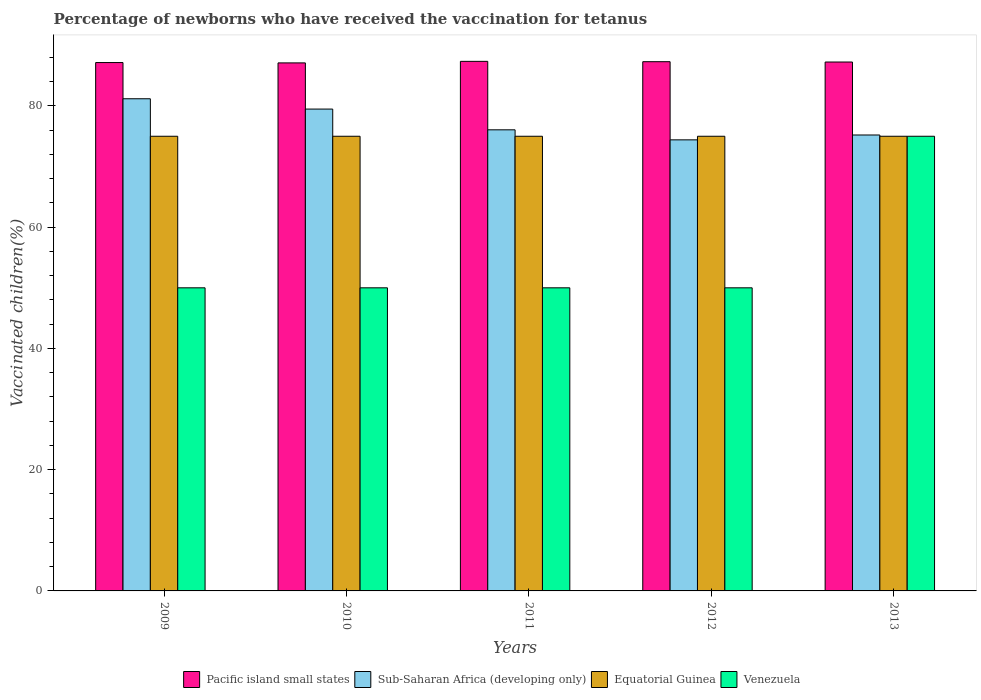How many different coloured bars are there?
Provide a short and direct response. 4. How many bars are there on the 5th tick from the left?
Your answer should be compact. 4. How many bars are there on the 1st tick from the right?
Offer a terse response. 4. What is the label of the 2nd group of bars from the left?
Your response must be concise. 2010. What is the percentage of vaccinated children in Venezuela in 2010?
Your answer should be very brief. 50. Across all years, what is the maximum percentage of vaccinated children in Pacific island small states?
Offer a terse response. 87.36. In which year was the percentage of vaccinated children in Equatorial Guinea minimum?
Offer a terse response. 2009. What is the total percentage of vaccinated children in Venezuela in the graph?
Make the answer very short. 275. What is the difference between the percentage of vaccinated children in Sub-Saharan Africa (developing only) in 2011 and that in 2013?
Your response must be concise. 0.85. What is the difference between the percentage of vaccinated children in Equatorial Guinea in 2012 and the percentage of vaccinated children in Sub-Saharan Africa (developing only) in 2013?
Keep it short and to the point. -0.21. In the year 2011, what is the difference between the percentage of vaccinated children in Pacific island small states and percentage of vaccinated children in Venezuela?
Your response must be concise. 37.36. In how many years, is the percentage of vaccinated children in Equatorial Guinea greater than 8 %?
Offer a terse response. 5. What is the ratio of the percentage of vaccinated children in Sub-Saharan Africa (developing only) in 2009 to that in 2011?
Offer a very short reply. 1.07. Is the percentage of vaccinated children in Venezuela in 2011 less than that in 2013?
Make the answer very short. Yes. Is the difference between the percentage of vaccinated children in Pacific island small states in 2011 and 2013 greater than the difference between the percentage of vaccinated children in Venezuela in 2011 and 2013?
Give a very brief answer. Yes. What is the difference between the highest and the lowest percentage of vaccinated children in Venezuela?
Give a very brief answer. 25. Is the sum of the percentage of vaccinated children in Equatorial Guinea in 2011 and 2012 greater than the maximum percentage of vaccinated children in Pacific island small states across all years?
Your response must be concise. Yes. Is it the case that in every year, the sum of the percentage of vaccinated children in Sub-Saharan Africa (developing only) and percentage of vaccinated children in Equatorial Guinea is greater than the sum of percentage of vaccinated children in Venezuela and percentage of vaccinated children in Pacific island small states?
Make the answer very short. Yes. What does the 3rd bar from the left in 2013 represents?
Give a very brief answer. Equatorial Guinea. What does the 4th bar from the right in 2011 represents?
Ensure brevity in your answer.  Pacific island small states. Is it the case that in every year, the sum of the percentage of vaccinated children in Venezuela and percentage of vaccinated children in Sub-Saharan Africa (developing only) is greater than the percentage of vaccinated children in Equatorial Guinea?
Give a very brief answer. Yes. How many bars are there?
Provide a succinct answer. 20. Are all the bars in the graph horizontal?
Offer a very short reply. No. How many years are there in the graph?
Provide a short and direct response. 5. Are the values on the major ticks of Y-axis written in scientific E-notation?
Provide a succinct answer. No. Where does the legend appear in the graph?
Ensure brevity in your answer.  Bottom center. How many legend labels are there?
Make the answer very short. 4. What is the title of the graph?
Provide a succinct answer. Percentage of newborns who have received the vaccination for tetanus. What is the label or title of the X-axis?
Keep it short and to the point. Years. What is the label or title of the Y-axis?
Your response must be concise. Vaccinated children(%). What is the Vaccinated children(%) in Pacific island small states in 2009?
Your answer should be compact. 87.16. What is the Vaccinated children(%) in Sub-Saharan Africa (developing only) in 2009?
Provide a succinct answer. 81.19. What is the Vaccinated children(%) in Equatorial Guinea in 2009?
Offer a terse response. 75. What is the Vaccinated children(%) of Pacific island small states in 2010?
Keep it short and to the point. 87.1. What is the Vaccinated children(%) in Sub-Saharan Africa (developing only) in 2010?
Offer a very short reply. 79.49. What is the Vaccinated children(%) in Equatorial Guinea in 2010?
Provide a short and direct response. 75. What is the Vaccinated children(%) in Pacific island small states in 2011?
Offer a terse response. 87.36. What is the Vaccinated children(%) of Sub-Saharan Africa (developing only) in 2011?
Keep it short and to the point. 76.06. What is the Vaccinated children(%) in Pacific island small states in 2012?
Your response must be concise. 87.3. What is the Vaccinated children(%) of Sub-Saharan Africa (developing only) in 2012?
Offer a very short reply. 74.41. What is the Vaccinated children(%) in Equatorial Guinea in 2012?
Make the answer very short. 75. What is the Vaccinated children(%) of Pacific island small states in 2013?
Make the answer very short. 87.25. What is the Vaccinated children(%) in Sub-Saharan Africa (developing only) in 2013?
Provide a short and direct response. 75.21. Across all years, what is the maximum Vaccinated children(%) in Pacific island small states?
Keep it short and to the point. 87.36. Across all years, what is the maximum Vaccinated children(%) of Sub-Saharan Africa (developing only)?
Your response must be concise. 81.19. Across all years, what is the maximum Vaccinated children(%) in Equatorial Guinea?
Provide a short and direct response. 75. Across all years, what is the maximum Vaccinated children(%) in Venezuela?
Provide a short and direct response. 75. Across all years, what is the minimum Vaccinated children(%) of Pacific island small states?
Provide a succinct answer. 87.1. Across all years, what is the minimum Vaccinated children(%) in Sub-Saharan Africa (developing only)?
Ensure brevity in your answer.  74.41. Across all years, what is the minimum Vaccinated children(%) in Equatorial Guinea?
Give a very brief answer. 75. What is the total Vaccinated children(%) of Pacific island small states in the graph?
Offer a very short reply. 436.17. What is the total Vaccinated children(%) of Sub-Saharan Africa (developing only) in the graph?
Provide a succinct answer. 386.35. What is the total Vaccinated children(%) of Equatorial Guinea in the graph?
Keep it short and to the point. 375. What is the total Vaccinated children(%) in Venezuela in the graph?
Keep it short and to the point. 275. What is the difference between the Vaccinated children(%) in Pacific island small states in 2009 and that in 2010?
Keep it short and to the point. 0.06. What is the difference between the Vaccinated children(%) in Sub-Saharan Africa (developing only) in 2009 and that in 2010?
Provide a short and direct response. 1.7. What is the difference between the Vaccinated children(%) of Equatorial Guinea in 2009 and that in 2010?
Your response must be concise. 0. What is the difference between the Vaccinated children(%) of Pacific island small states in 2009 and that in 2011?
Your answer should be compact. -0.2. What is the difference between the Vaccinated children(%) of Sub-Saharan Africa (developing only) in 2009 and that in 2011?
Keep it short and to the point. 5.13. What is the difference between the Vaccinated children(%) of Equatorial Guinea in 2009 and that in 2011?
Offer a very short reply. 0. What is the difference between the Vaccinated children(%) of Pacific island small states in 2009 and that in 2012?
Ensure brevity in your answer.  -0.14. What is the difference between the Vaccinated children(%) of Sub-Saharan Africa (developing only) in 2009 and that in 2012?
Make the answer very short. 6.78. What is the difference between the Vaccinated children(%) in Venezuela in 2009 and that in 2012?
Provide a succinct answer. 0. What is the difference between the Vaccinated children(%) in Pacific island small states in 2009 and that in 2013?
Keep it short and to the point. -0.09. What is the difference between the Vaccinated children(%) in Sub-Saharan Africa (developing only) in 2009 and that in 2013?
Make the answer very short. 5.98. What is the difference between the Vaccinated children(%) of Venezuela in 2009 and that in 2013?
Give a very brief answer. -25. What is the difference between the Vaccinated children(%) of Pacific island small states in 2010 and that in 2011?
Give a very brief answer. -0.25. What is the difference between the Vaccinated children(%) of Sub-Saharan Africa (developing only) in 2010 and that in 2011?
Your answer should be compact. 3.42. What is the difference between the Vaccinated children(%) of Venezuela in 2010 and that in 2011?
Offer a very short reply. 0. What is the difference between the Vaccinated children(%) in Pacific island small states in 2010 and that in 2012?
Your answer should be very brief. -0.2. What is the difference between the Vaccinated children(%) in Sub-Saharan Africa (developing only) in 2010 and that in 2012?
Keep it short and to the point. 5.08. What is the difference between the Vaccinated children(%) in Venezuela in 2010 and that in 2012?
Give a very brief answer. 0. What is the difference between the Vaccinated children(%) in Pacific island small states in 2010 and that in 2013?
Your answer should be very brief. -0.14. What is the difference between the Vaccinated children(%) in Sub-Saharan Africa (developing only) in 2010 and that in 2013?
Your answer should be compact. 4.28. What is the difference between the Vaccinated children(%) in Equatorial Guinea in 2010 and that in 2013?
Provide a short and direct response. 0. What is the difference between the Vaccinated children(%) of Venezuela in 2010 and that in 2013?
Offer a terse response. -25. What is the difference between the Vaccinated children(%) of Pacific island small states in 2011 and that in 2012?
Your response must be concise. 0.06. What is the difference between the Vaccinated children(%) in Sub-Saharan Africa (developing only) in 2011 and that in 2012?
Provide a short and direct response. 1.65. What is the difference between the Vaccinated children(%) in Equatorial Guinea in 2011 and that in 2012?
Offer a terse response. 0. What is the difference between the Vaccinated children(%) of Venezuela in 2011 and that in 2012?
Keep it short and to the point. 0. What is the difference between the Vaccinated children(%) in Pacific island small states in 2011 and that in 2013?
Ensure brevity in your answer.  0.11. What is the difference between the Vaccinated children(%) in Sub-Saharan Africa (developing only) in 2011 and that in 2013?
Your answer should be compact. 0.85. What is the difference between the Vaccinated children(%) in Venezuela in 2011 and that in 2013?
Give a very brief answer. -25. What is the difference between the Vaccinated children(%) in Pacific island small states in 2012 and that in 2013?
Make the answer very short. 0.06. What is the difference between the Vaccinated children(%) in Sub-Saharan Africa (developing only) in 2012 and that in 2013?
Provide a short and direct response. -0.8. What is the difference between the Vaccinated children(%) in Equatorial Guinea in 2012 and that in 2013?
Your answer should be very brief. 0. What is the difference between the Vaccinated children(%) of Pacific island small states in 2009 and the Vaccinated children(%) of Sub-Saharan Africa (developing only) in 2010?
Your answer should be compact. 7.67. What is the difference between the Vaccinated children(%) of Pacific island small states in 2009 and the Vaccinated children(%) of Equatorial Guinea in 2010?
Give a very brief answer. 12.16. What is the difference between the Vaccinated children(%) in Pacific island small states in 2009 and the Vaccinated children(%) in Venezuela in 2010?
Ensure brevity in your answer.  37.16. What is the difference between the Vaccinated children(%) in Sub-Saharan Africa (developing only) in 2009 and the Vaccinated children(%) in Equatorial Guinea in 2010?
Offer a terse response. 6.19. What is the difference between the Vaccinated children(%) of Sub-Saharan Africa (developing only) in 2009 and the Vaccinated children(%) of Venezuela in 2010?
Offer a very short reply. 31.19. What is the difference between the Vaccinated children(%) in Equatorial Guinea in 2009 and the Vaccinated children(%) in Venezuela in 2010?
Provide a short and direct response. 25. What is the difference between the Vaccinated children(%) of Pacific island small states in 2009 and the Vaccinated children(%) of Sub-Saharan Africa (developing only) in 2011?
Offer a terse response. 11.1. What is the difference between the Vaccinated children(%) in Pacific island small states in 2009 and the Vaccinated children(%) in Equatorial Guinea in 2011?
Keep it short and to the point. 12.16. What is the difference between the Vaccinated children(%) of Pacific island small states in 2009 and the Vaccinated children(%) of Venezuela in 2011?
Ensure brevity in your answer.  37.16. What is the difference between the Vaccinated children(%) in Sub-Saharan Africa (developing only) in 2009 and the Vaccinated children(%) in Equatorial Guinea in 2011?
Offer a very short reply. 6.19. What is the difference between the Vaccinated children(%) in Sub-Saharan Africa (developing only) in 2009 and the Vaccinated children(%) in Venezuela in 2011?
Your response must be concise. 31.19. What is the difference between the Vaccinated children(%) of Pacific island small states in 2009 and the Vaccinated children(%) of Sub-Saharan Africa (developing only) in 2012?
Provide a short and direct response. 12.75. What is the difference between the Vaccinated children(%) of Pacific island small states in 2009 and the Vaccinated children(%) of Equatorial Guinea in 2012?
Keep it short and to the point. 12.16. What is the difference between the Vaccinated children(%) in Pacific island small states in 2009 and the Vaccinated children(%) in Venezuela in 2012?
Your answer should be compact. 37.16. What is the difference between the Vaccinated children(%) of Sub-Saharan Africa (developing only) in 2009 and the Vaccinated children(%) of Equatorial Guinea in 2012?
Provide a short and direct response. 6.19. What is the difference between the Vaccinated children(%) in Sub-Saharan Africa (developing only) in 2009 and the Vaccinated children(%) in Venezuela in 2012?
Provide a short and direct response. 31.19. What is the difference between the Vaccinated children(%) in Pacific island small states in 2009 and the Vaccinated children(%) in Sub-Saharan Africa (developing only) in 2013?
Offer a terse response. 11.95. What is the difference between the Vaccinated children(%) in Pacific island small states in 2009 and the Vaccinated children(%) in Equatorial Guinea in 2013?
Your answer should be compact. 12.16. What is the difference between the Vaccinated children(%) in Pacific island small states in 2009 and the Vaccinated children(%) in Venezuela in 2013?
Your answer should be very brief. 12.16. What is the difference between the Vaccinated children(%) in Sub-Saharan Africa (developing only) in 2009 and the Vaccinated children(%) in Equatorial Guinea in 2013?
Ensure brevity in your answer.  6.19. What is the difference between the Vaccinated children(%) of Sub-Saharan Africa (developing only) in 2009 and the Vaccinated children(%) of Venezuela in 2013?
Your response must be concise. 6.19. What is the difference between the Vaccinated children(%) in Pacific island small states in 2010 and the Vaccinated children(%) in Sub-Saharan Africa (developing only) in 2011?
Offer a very short reply. 11.04. What is the difference between the Vaccinated children(%) of Pacific island small states in 2010 and the Vaccinated children(%) of Equatorial Guinea in 2011?
Provide a succinct answer. 12.1. What is the difference between the Vaccinated children(%) in Pacific island small states in 2010 and the Vaccinated children(%) in Venezuela in 2011?
Keep it short and to the point. 37.1. What is the difference between the Vaccinated children(%) of Sub-Saharan Africa (developing only) in 2010 and the Vaccinated children(%) of Equatorial Guinea in 2011?
Your answer should be very brief. 4.49. What is the difference between the Vaccinated children(%) of Sub-Saharan Africa (developing only) in 2010 and the Vaccinated children(%) of Venezuela in 2011?
Your response must be concise. 29.49. What is the difference between the Vaccinated children(%) of Pacific island small states in 2010 and the Vaccinated children(%) of Sub-Saharan Africa (developing only) in 2012?
Ensure brevity in your answer.  12.69. What is the difference between the Vaccinated children(%) in Pacific island small states in 2010 and the Vaccinated children(%) in Equatorial Guinea in 2012?
Make the answer very short. 12.1. What is the difference between the Vaccinated children(%) in Pacific island small states in 2010 and the Vaccinated children(%) in Venezuela in 2012?
Your answer should be compact. 37.1. What is the difference between the Vaccinated children(%) of Sub-Saharan Africa (developing only) in 2010 and the Vaccinated children(%) of Equatorial Guinea in 2012?
Provide a short and direct response. 4.49. What is the difference between the Vaccinated children(%) of Sub-Saharan Africa (developing only) in 2010 and the Vaccinated children(%) of Venezuela in 2012?
Make the answer very short. 29.49. What is the difference between the Vaccinated children(%) in Pacific island small states in 2010 and the Vaccinated children(%) in Sub-Saharan Africa (developing only) in 2013?
Make the answer very short. 11.89. What is the difference between the Vaccinated children(%) in Pacific island small states in 2010 and the Vaccinated children(%) in Equatorial Guinea in 2013?
Give a very brief answer. 12.1. What is the difference between the Vaccinated children(%) of Pacific island small states in 2010 and the Vaccinated children(%) of Venezuela in 2013?
Give a very brief answer. 12.1. What is the difference between the Vaccinated children(%) in Sub-Saharan Africa (developing only) in 2010 and the Vaccinated children(%) in Equatorial Guinea in 2013?
Make the answer very short. 4.49. What is the difference between the Vaccinated children(%) of Sub-Saharan Africa (developing only) in 2010 and the Vaccinated children(%) of Venezuela in 2013?
Keep it short and to the point. 4.49. What is the difference between the Vaccinated children(%) of Equatorial Guinea in 2010 and the Vaccinated children(%) of Venezuela in 2013?
Your answer should be compact. 0. What is the difference between the Vaccinated children(%) of Pacific island small states in 2011 and the Vaccinated children(%) of Sub-Saharan Africa (developing only) in 2012?
Ensure brevity in your answer.  12.95. What is the difference between the Vaccinated children(%) of Pacific island small states in 2011 and the Vaccinated children(%) of Equatorial Guinea in 2012?
Ensure brevity in your answer.  12.36. What is the difference between the Vaccinated children(%) in Pacific island small states in 2011 and the Vaccinated children(%) in Venezuela in 2012?
Your response must be concise. 37.36. What is the difference between the Vaccinated children(%) in Sub-Saharan Africa (developing only) in 2011 and the Vaccinated children(%) in Equatorial Guinea in 2012?
Make the answer very short. 1.06. What is the difference between the Vaccinated children(%) of Sub-Saharan Africa (developing only) in 2011 and the Vaccinated children(%) of Venezuela in 2012?
Provide a short and direct response. 26.06. What is the difference between the Vaccinated children(%) of Equatorial Guinea in 2011 and the Vaccinated children(%) of Venezuela in 2012?
Ensure brevity in your answer.  25. What is the difference between the Vaccinated children(%) in Pacific island small states in 2011 and the Vaccinated children(%) in Sub-Saharan Africa (developing only) in 2013?
Offer a terse response. 12.15. What is the difference between the Vaccinated children(%) in Pacific island small states in 2011 and the Vaccinated children(%) in Equatorial Guinea in 2013?
Offer a very short reply. 12.36. What is the difference between the Vaccinated children(%) in Pacific island small states in 2011 and the Vaccinated children(%) in Venezuela in 2013?
Make the answer very short. 12.36. What is the difference between the Vaccinated children(%) of Sub-Saharan Africa (developing only) in 2011 and the Vaccinated children(%) of Equatorial Guinea in 2013?
Your response must be concise. 1.06. What is the difference between the Vaccinated children(%) of Sub-Saharan Africa (developing only) in 2011 and the Vaccinated children(%) of Venezuela in 2013?
Ensure brevity in your answer.  1.06. What is the difference between the Vaccinated children(%) of Pacific island small states in 2012 and the Vaccinated children(%) of Sub-Saharan Africa (developing only) in 2013?
Your answer should be compact. 12.09. What is the difference between the Vaccinated children(%) in Pacific island small states in 2012 and the Vaccinated children(%) in Equatorial Guinea in 2013?
Offer a terse response. 12.3. What is the difference between the Vaccinated children(%) in Pacific island small states in 2012 and the Vaccinated children(%) in Venezuela in 2013?
Offer a very short reply. 12.3. What is the difference between the Vaccinated children(%) in Sub-Saharan Africa (developing only) in 2012 and the Vaccinated children(%) in Equatorial Guinea in 2013?
Offer a terse response. -0.59. What is the difference between the Vaccinated children(%) of Sub-Saharan Africa (developing only) in 2012 and the Vaccinated children(%) of Venezuela in 2013?
Your answer should be very brief. -0.59. What is the average Vaccinated children(%) in Pacific island small states per year?
Provide a succinct answer. 87.23. What is the average Vaccinated children(%) in Sub-Saharan Africa (developing only) per year?
Your response must be concise. 77.27. What is the average Vaccinated children(%) in Equatorial Guinea per year?
Keep it short and to the point. 75. In the year 2009, what is the difference between the Vaccinated children(%) of Pacific island small states and Vaccinated children(%) of Sub-Saharan Africa (developing only)?
Your answer should be compact. 5.97. In the year 2009, what is the difference between the Vaccinated children(%) in Pacific island small states and Vaccinated children(%) in Equatorial Guinea?
Provide a succinct answer. 12.16. In the year 2009, what is the difference between the Vaccinated children(%) of Pacific island small states and Vaccinated children(%) of Venezuela?
Ensure brevity in your answer.  37.16. In the year 2009, what is the difference between the Vaccinated children(%) of Sub-Saharan Africa (developing only) and Vaccinated children(%) of Equatorial Guinea?
Offer a terse response. 6.19. In the year 2009, what is the difference between the Vaccinated children(%) of Sub-Saharan Africa (developing only) and Vaccinated children(%) of Venezuela?
Keep it short and to the point. 31.19. In the year 2010, what is the difference between the Vaccinated children(%) in Pacific island small states and Vaccinated children(%) in Sub-Saharan Africa (developing only)?
Your answer should be very brief. 7.62. In the year 2010, what is the difference between the Vaccinated children(%) of Pacific island small states and Vaccinated children(%) of Equatorial Guinea?
Provide a short and direct response. 12.1. In the year 2010, what is the difference between the Vaccinated children(%) in Pacific island small states and Vaccinated children(%) in Venezuela?
Your response must be concise. 37.1. In the year 2010, what is the difference between the Vaccinated children(%) of Sub-Saharan Africa (developing only) and Vaccinated children(%) of Equatorial Guinea?
Offer a terse response. 4.49. In the year 2010, what is the difference between the Vaccinated children(%) of Sub-Saharan Africa (developing only) and Vaccinated children(%) of Venezuela?
Offer a very short reply. 29.49. In the year 2010, what is the difference between the Vaccinated children(%) of Equatorial Guinea and Vaccinated children(%) of Venezuela?
Provide a succinct answer. 25. In the year 2011, what is the difference between the Vaccinated children(%) of Pacific island small states and Vaccinated children(%) of Sub-Saharan Africa (developing only)?
Provide a short and direct response. 11.3. In the year 2011, what is the difference between the Vaccinated children(%) of Pacific island small states and Vaccinated children(%) of Equatorial Guinea?
Keep it short and to the point. 12.36. In the year 2011, what is the difference between the Vaccinated children(%) of Pacific island small states and Vaccinated children(%) of Venezuela?
Provide a succinct answer. 37.36. In the year 2011, what is the difference between the Vaccinated children(%) of Sub-Saharan Africa (developing only) and Vaccinated children(%) of Equatorial Guinea?
Offer a very short reply. 1.06. In the year 2011, what is the difference between the Vaccinated children(%) of Sub-Saharan Africa (developing only) and Vaccinated children(%) of Venezuela?
Give a very brief answer. 26.06. In the year 2012, what is the difference between the Vaccinated children(%) in Pacific island small states and Vaccinated children(%) in Sub-Saharan Africa (developing only)?
Your answer should be very brief. 12.89. In the year 2012, what is the difference between the Vaccinated children(%) of Pacific island small states and Vaccinated children(%) of Equatorial Guinea?
Your answer should be very brief. 12.3. In the year 2012, what is the difference between the Vaccinated children(%) of Pacific island small states and Vaccinated children(%) of Venezuela?
Provide a succinct answer. 37.3. In the year 2012, what is the difference between the Vaccinated children(%) of Sub-Saharan Africa (developing only) and Vaccinated children(%) of Equatorial Guinea?
Your response must be concise. -0.59. In the year 2012, what is the difference between the Vaccinated children(%) in Sub-Saharan Africa (developing only) and Vaccinated children(%) in Venezuela?
Your response must be concise. 24.41. In the year 2012, what is the difference between the Vaccinated children(%) in Equatorial Guinea and Vaccinated children(%) in Venezuela?
Make the answer very short. 25. In the year 2013, what is the difference between the Vaccinated children(%) of Pacific island small states and Vaccinated children(%) of Sub-Saharan Africa (developing only)?
Keep it short and to the point. 12.04. In the year 2013, what is the difference between the Vaccinated children(%) of Pacific island small states and Vaccinated children(%) of Equatorial Guinea?
Offer a very short reply. 12.25. In the year 2013, what is the difference between the Vaccinated children(%) in Pacific island small states and Vaccinated children(%) in Venezuela?
Ensure brevity in your answer.  12.25. In the year 2013, what is the difference between the Vaccinated children(%) of Sub-Saharan Africa (developing only) and Vaccinated children(%) of Equatorial Guinea?
Provide a succinct answer. 0.21. In the year 2013, what is the difference between the Vaccinated children(%) of Sub-Saharan Africa (developing only) and Vaccinated children(%) of Venezuela?
Keep it short and to the point. 0.21. In the year 2013, what is the difference between the Vaccinated children(%) of Equatorial Guinea and Vaccinated children(%) of Venezuela?
Ensure brevity in your answer.  0. What is the ratio of the Vaccinated children(%) of Sub-Saharan Africa (developing only) in 2009 to that in 2010?
Give a very brief answer. 1.02. What is the ratio of the Vaccinated children(%) of Sub-Saharan Africa (developing only) in 2009 to that in 2011?
Your answer should be compact. 1.07. What is the ratio of the Vaccinated children(%) in Sub-Saharan Africa (developing only) in 2009 to that in 2012?
Offer a terse response. 1.09. What is the ratio of the Vaccinated children(%) of Equatorial Guinea in 2009 to that in 2012?
Provide a short and direct response. 1. What is the ratio of the Vaccinated children(%) of Sub-Saharan Africa (developing only) in 2009 to that in 2013?
Ensure brevity in your answer.  1.08. What is the ratio of the Vaccinated children(%) of Venezuela in 2009 to that in 2013?
Your answer should be very brief. 0.67. What is the ratio of the Vaccinated children(%) of Pacific island small states in 2010 to that in 2011?
Ensure brevity in your answer.  1. What is the ratio of the Vaccinated children(%) in Sub-Saharan Africa (developing only) in 2010 to that in 2011?
Ensure brevity in your answer.  1.04. What is the ratio of the Vaccinated children(%) of Equatorial Guinea in 2010 to that in 2011?
Provide a short and direct response. 1. What is the ratio of the Vaccinated children(%) in Venezuela in 2010 to that in 2011?
Give a very brief answer. 1. What is the ratio of the Vaccinated children(%) in Sub-Saharan Africa (developing only) in 2010 to that in 2012?
Make the answer very short. 1.07. What is the ratio of the Vaccinated children(%) in Sub-Saharan Africa (developing only) in 2010 to that in 2013?
Your answer should be very brief. 1.06. What is the ratio of the Vaccinated children(%) in Pacific island small states in 2011 to that in 2012?
Your answer should be very brief. 1. What is the ratio of the Vaccinated children(%) in Sub-Saharan Africa (developing only) in 2011 to that in 2012?
Give a very brief answer. 1.02. What is the ratio of the Vaccinated children(%) in Venezuela in 2011 to that in 2012?
Provide a short and direct response. 1. What is the ratio of the Vaccinated children(%) in Sub-Saharan Africa (developing only) in 2011 to that in 2013?
Ensure brevity in your answer.  1.01. What is the ratio of the Vaccinated children(%) in Equatorial Guinea in 2011 to that in 2013?
Make the answer very short. 1. What is the ratio of the Vaccinated children(%) of Venezuela in 2011 to that in 2013?
Offer a terse response. 0.67. What is the ratio of the Vaccinated children(%) of Pacific island small states in 2012 to that in 2013?
Your response must be concise. 1. What is the ratio of the Vaccinated children(%) in Sub-Saharan Africa (developing only) in 2012 to that in 2013?
Your answer should be compact. 0.99. What is the ratio of the Vaccinated children(%) of Equatorial Guinea in 2012 to that in 2013?
Your answer should be compact. 1. What is the ratio of the Vaccinated children(%) of Venezuela in 2012 to that in 2013?
Offer a very short reply. 0.67. What is the difference between the highest and the second highest Vaccinated children(%) in Pacific island small states?
Your answer should be very brief. 0.06. What is the difference between the highest and the second highest Vaccinated children(%) of Sub-Saharan Africa (developing only)?
Your answer should be very brief. 1.7. What is the difference between the highest and the second highest Vaccinated children(%) in Equatorial Guinea?
Make the answer very short. 0. What is the difference between the highest and the lowest Vaccinated children(%) in Pacific island small states?
Provide a short and direct response. 0.25. What is the difference between the highest and the lowest Vaccinated children(%) of Sub-Saharan Africa (developing only)?
Your response must be concise. 6.78. 